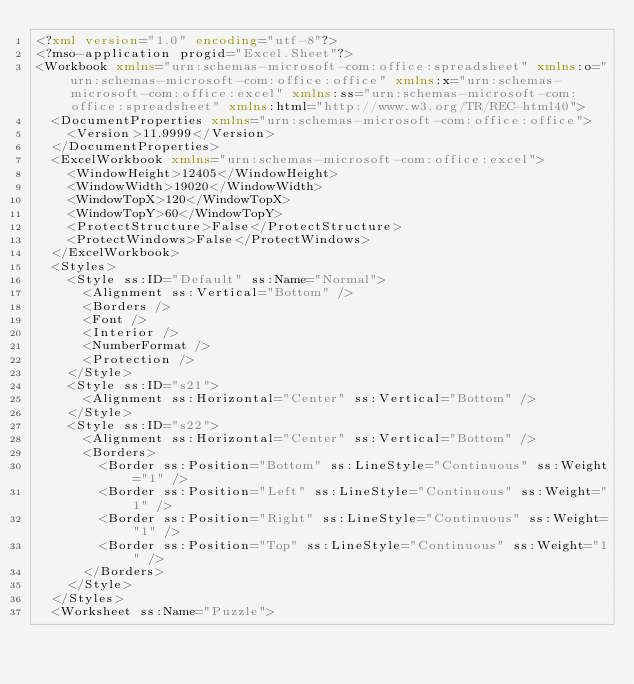<code> <loc_0><loc_0><loc_500><loc_500><_XML_><?xml version="1.0" encoding="utf-8"?>
<?mso-application progid="Excel.Sheet"?>
<Workbook xmlns="urn:schemas-microsoft-com:office:spreadsheet" xmlns:o="urn:schemas-microsoft-com:office:office" xmlns:x="urn:schemas-microsoft-com:office:excel" xmlns:ss="urn:schemas-microsoft-com:office:spreadsheet" xmlns:html="http://www.w3.org/TR/REC-html40">
  <DocumentProperties xmlns="urn:schemas-microsoft-com:office:office">
    <Version>11.9999</Version>
  </DocumentProperties>
  <ExcelWorkbook xmlns="urn:schemas-microsoft-com:office:excel">
    <WindowHeight>12405</WindowHeight>
    <WindowWidth>19020</WindowWidth>
    <WindowTopX>120</WindowTopX>
    <WindowTopY>60</WindowTopY>
    <ProtectStructure>False</ProtectStructure>
    <ProtectWindows>False</ProtectWindows>
  </ExcelWorkbook>
  <Styles>
    <Style ss:ID="Default" ss:Name="Normal">
      <Alignment ss:Vertical="Bottom" />
      <Borders />
      <Font />
      <Interior />
      <NumberFormat />
      <Protection />
    </Style>
    <Style ss:ID="s21">
      <Alignment ss:Horizontal="Center" ss:Vertical="Bottom" />
    </Style>
    <Style ss:ID="s22">
      <Alignment ss:Horizontal="Center" ss:Vertical="Bottom" />
      <Borders>
        <Border ss:Position="Bottom" ss:LineStyle="Continuous" ss:Weight="1" />
        <Border ss:Position="Left" ss:LineStyle="Continuous" ss:Weight="1" />
        <Border ss:Position="Right" ss:LineStyle="Continuous" ss:Weight="1" />
        <Border ss:Position="Top" ss:LineStyle="Continuous" ss:Weight="1" />
      </Borders>
    </Style>
  </Styles>
  <Worksheet ss:Name="Puzzle"></code> 